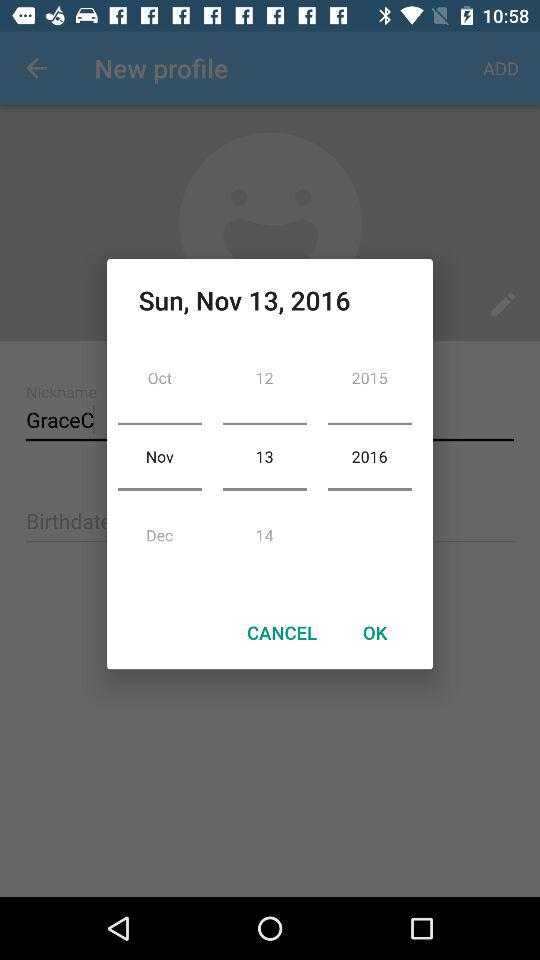What is the selected date? The selected date is November 13, 2016. 